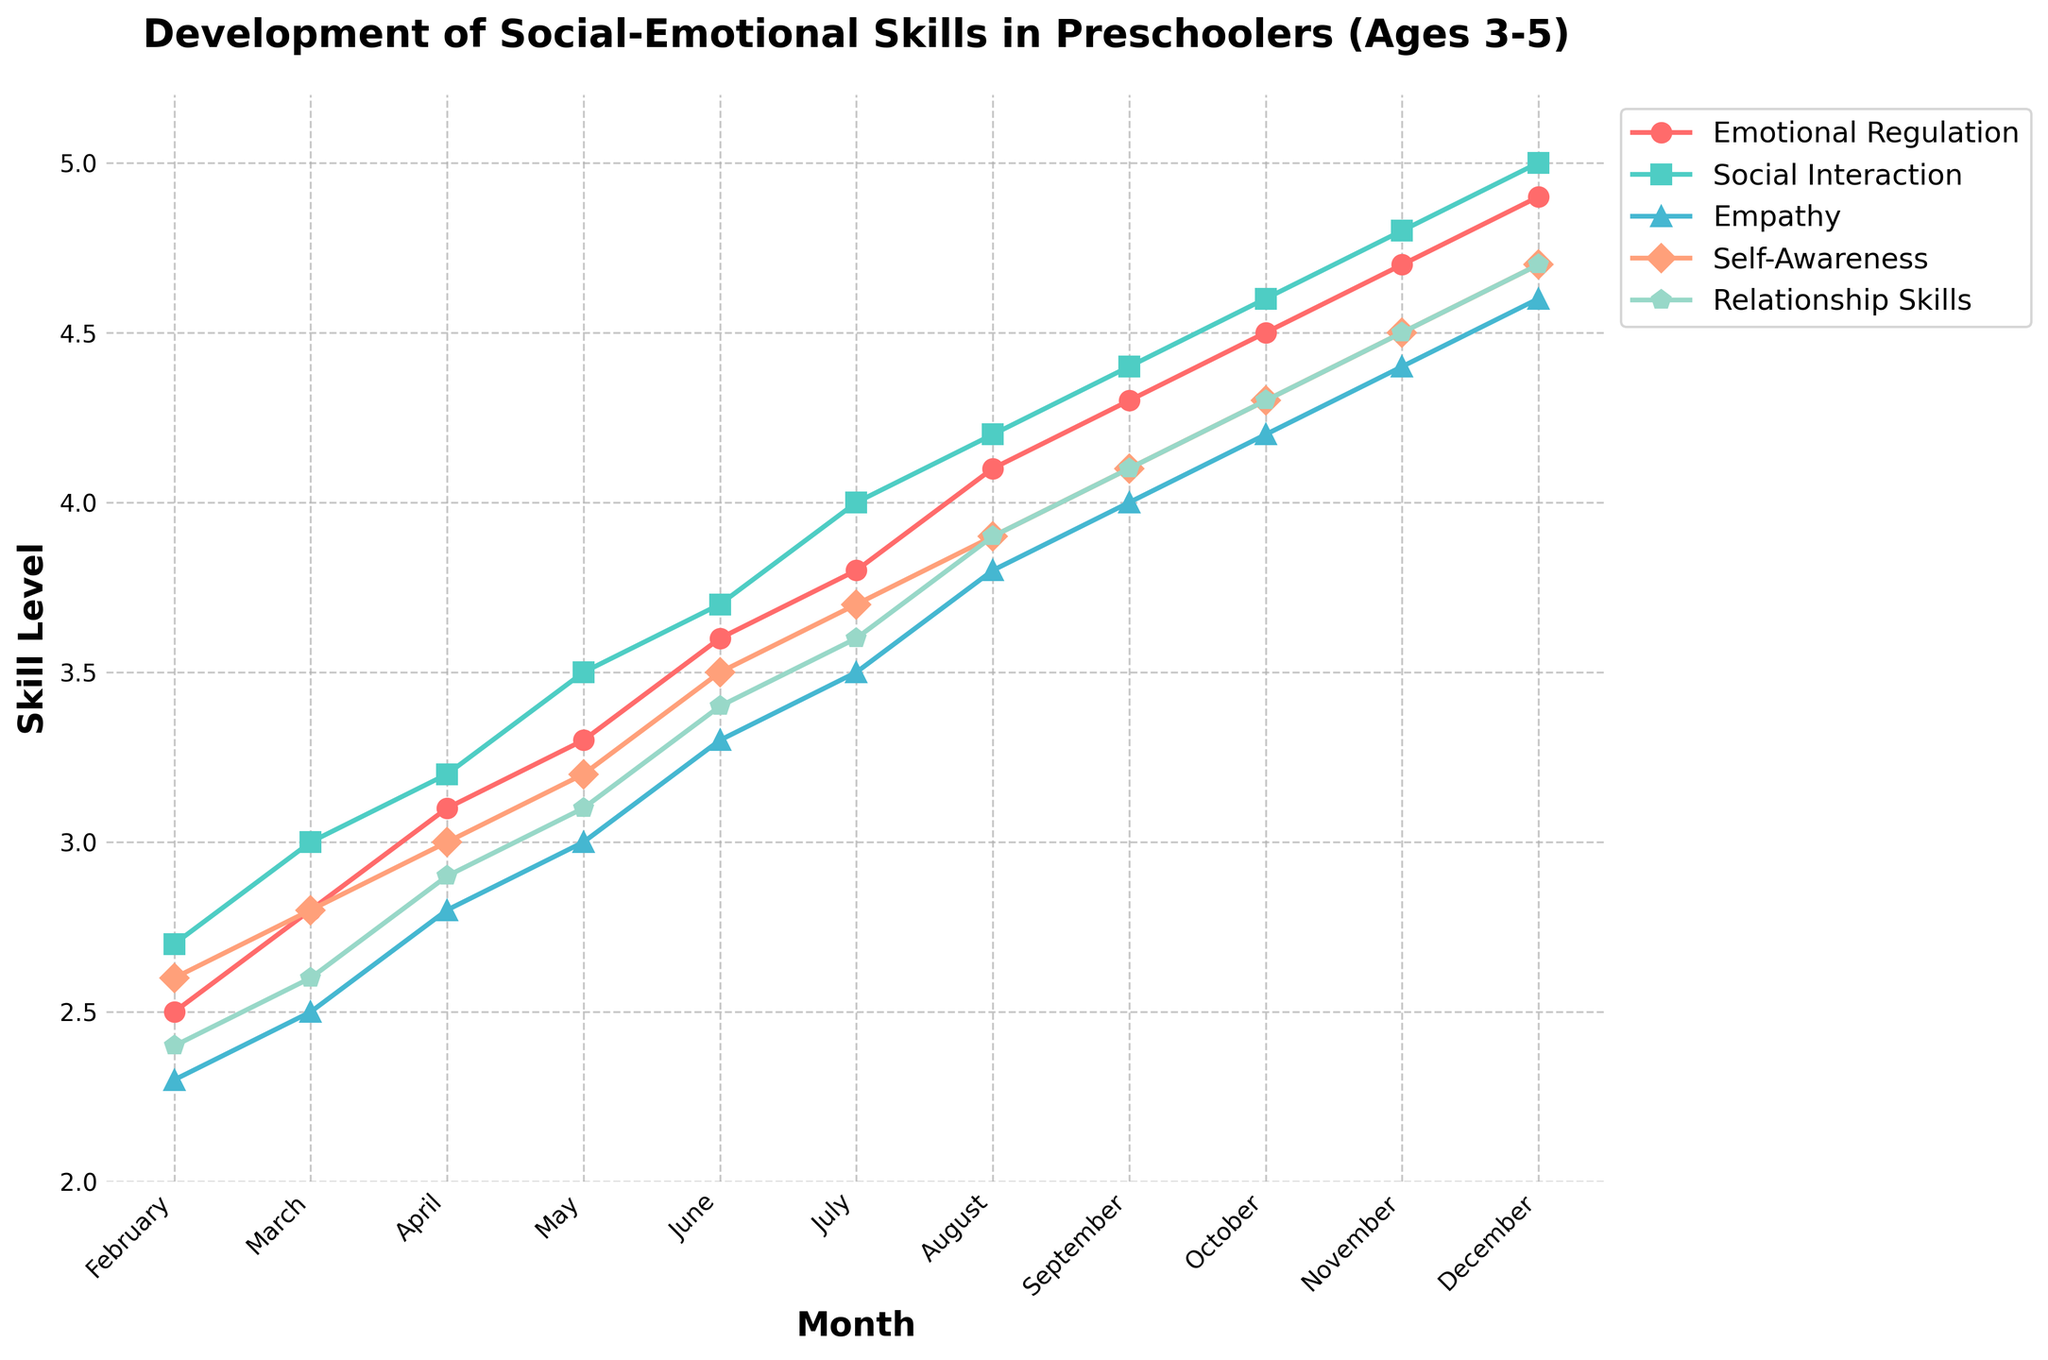How does the level of empathy in May compare to the level in December? In May, the level of empathy is 3.0. In December, it rises to 4.6. Therefore, empathy in December is higher than in May by 1.6.
Answer: 1.6 What is the average skill level of social interaction from February to April? From February to April, the levels for social interaction are 2.7, 3.0, and 3.2 respectively. The average is calculated as (2.7 + 3.0 + 3.2) / 3 = 2.97.
Answer: 2.97 Which skill has the highest level in November, and what is its value? In November, the levels of Emotional Regulation, Social Interaction, Empathy, Self-Awareness, and Relationship Skills are 4.7, 4.8, 4.4, 4.5, and 4.5 respectively. Social Interaction has the highest level of 4.8.
Answer: Social Interaction, 4.8 By how much did the level of self-awareness increase from February to June? In February, the self-awareness level is 2.6. By June, it has increased to 3.5. The increase is calculated as 3.5 - 2.6 = 0.9.
Answer: 0.9 Which months show the same level for relationship skills and social interaction? We need to check each month to find equal values. In November, Relationship Skills and Social Interaction both have a level of 4.5.
Answer: November Between which months does emotional regulation show the steepest increase? To identify the steepest increase, we examine month-to-month differences. The increase from February (2.5) to March (2.8) is 0.3, from March to April (3.1) is 0.3, April to May (3.3) is 0.2, etc. The largest increase is from April to May (0.4).
Answer: April to May Compare the empathy and emotional regulation trends between March and August. Which skill shows greater improvement? From March to August, empathy moves from 2.5 to 3.8, an improvement of 1.3. Emotional regulation moves from 2.8 to 4.1, an improvement of 1.3. Both skills show the same improvement.
Answer: Same improvement (1.3) What is the total increase in relationship skills from the beginning to the end of the school year? Relationship skills start at 2.4 in February and reach 4.7 by December. The total increase is 4.7 - 2.4 = 2.3.
Answer: 2.3 Identify the month in which empathy levels first exceed 4.0 and state the exact value. Looking at the empathy levels, they exceed 4.0 in September for the first time, with a value of 4.0.
Answer: September, 4.0 